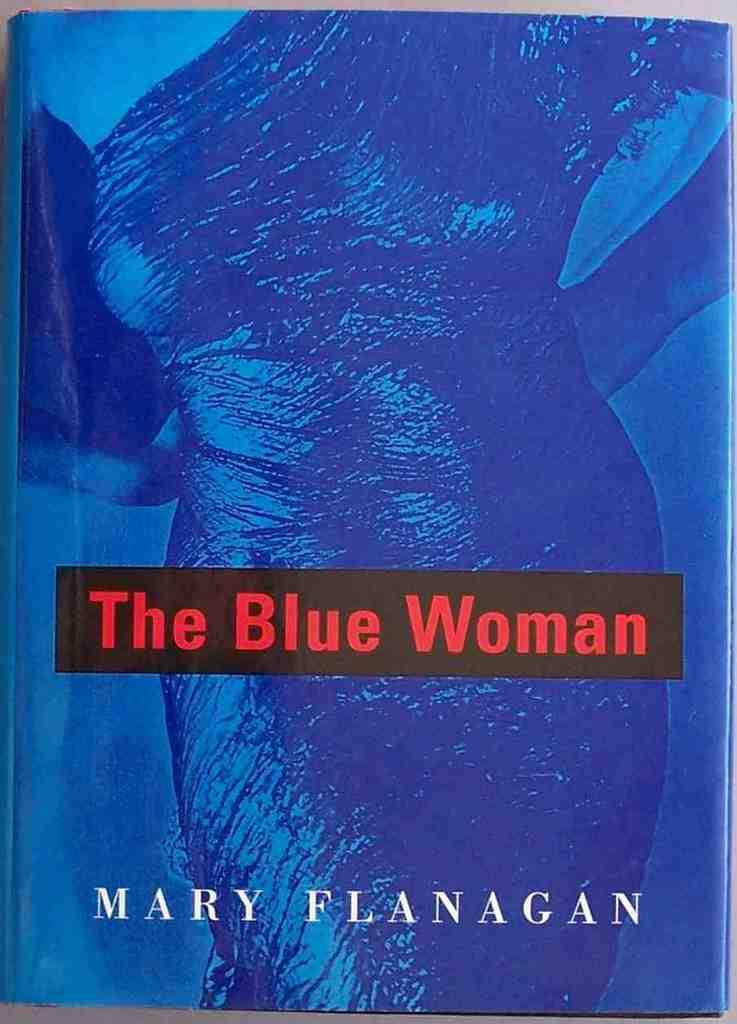<image>
Provide a brief description of the given image. A book titled The Blue Woman by Mary Flanagan. 